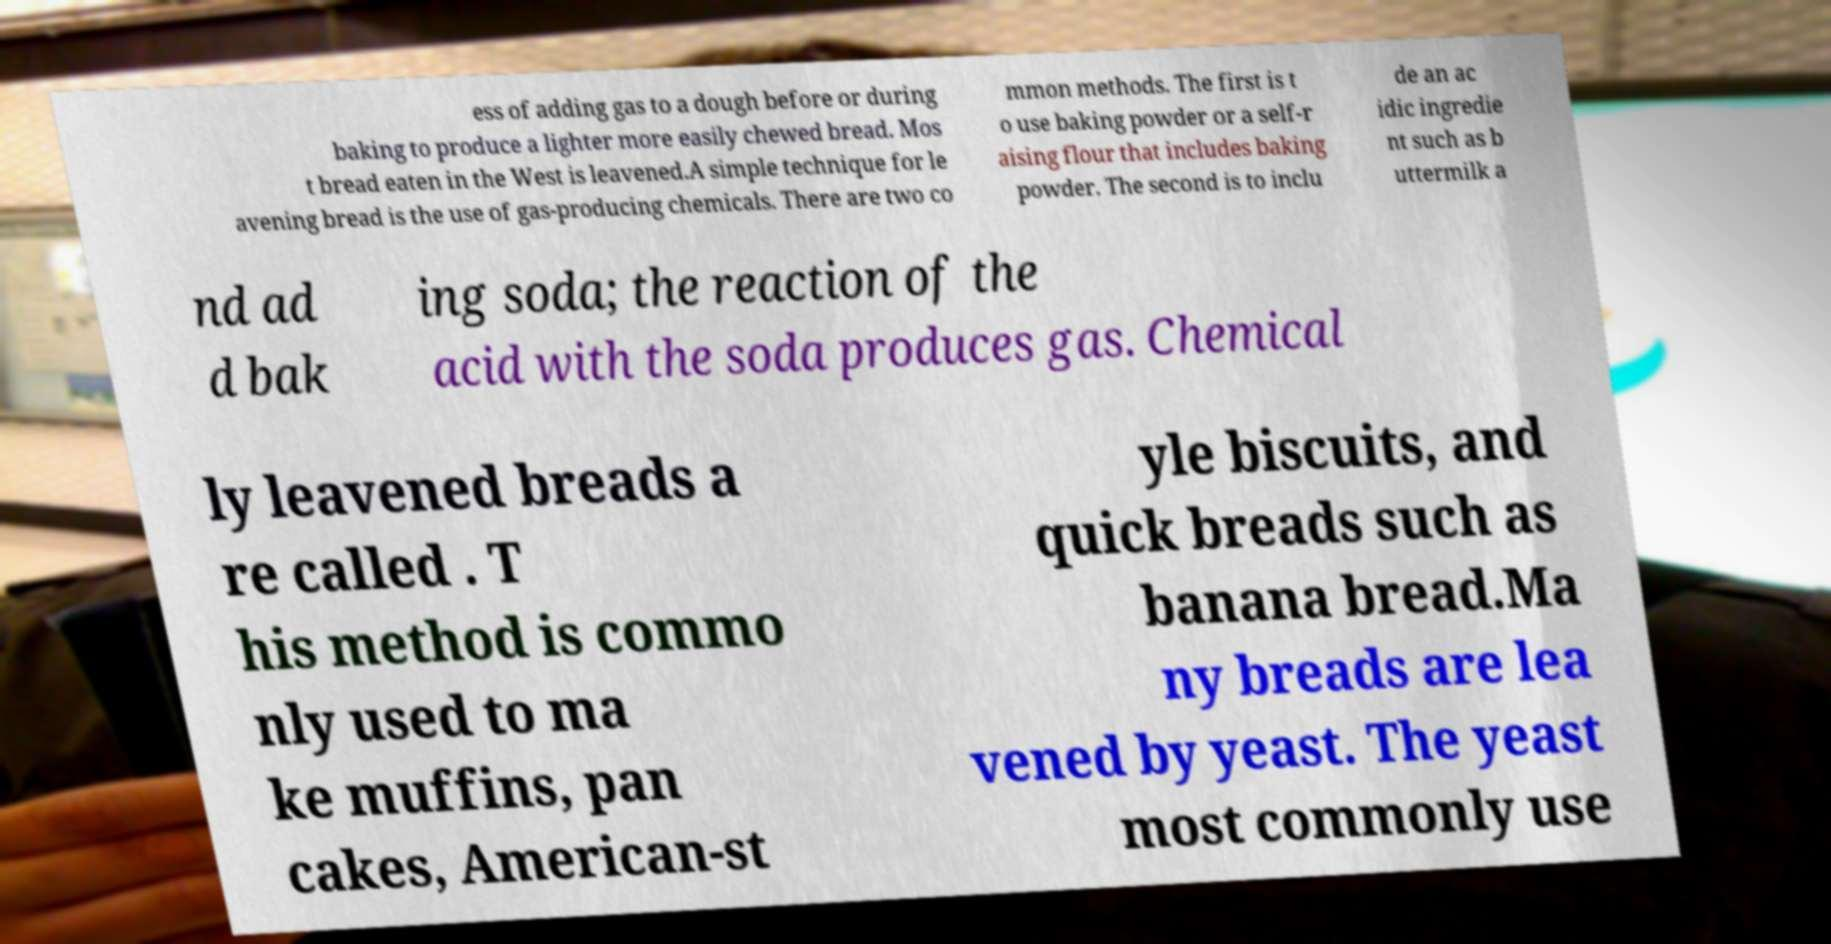Could you extract and type out the text from this image? ess of adding gas to a dough before or during baking to produce a lighter more easily chewed bread. Mos t bread eaten in the West is leavened.A simple technique for le avening bread is the use of gas-producing chemicals. There are two co mmon methods. The first is t o use baking powder or a self-r aising flour that includes baking powder. The second is to inclu de an ac idic ingredie nt such as b uttermilk a nd ad d bak ing soda; the reaction of the acid with the soda produces gas. Chemical ly leavened breads a re called . T his method is commo nly used to ma ke muffins, pan cakes, American-st yle biscuits, and quick breads such as banana bread.Ma ny breads are lea vened by yeast. The yeast most commonly use 